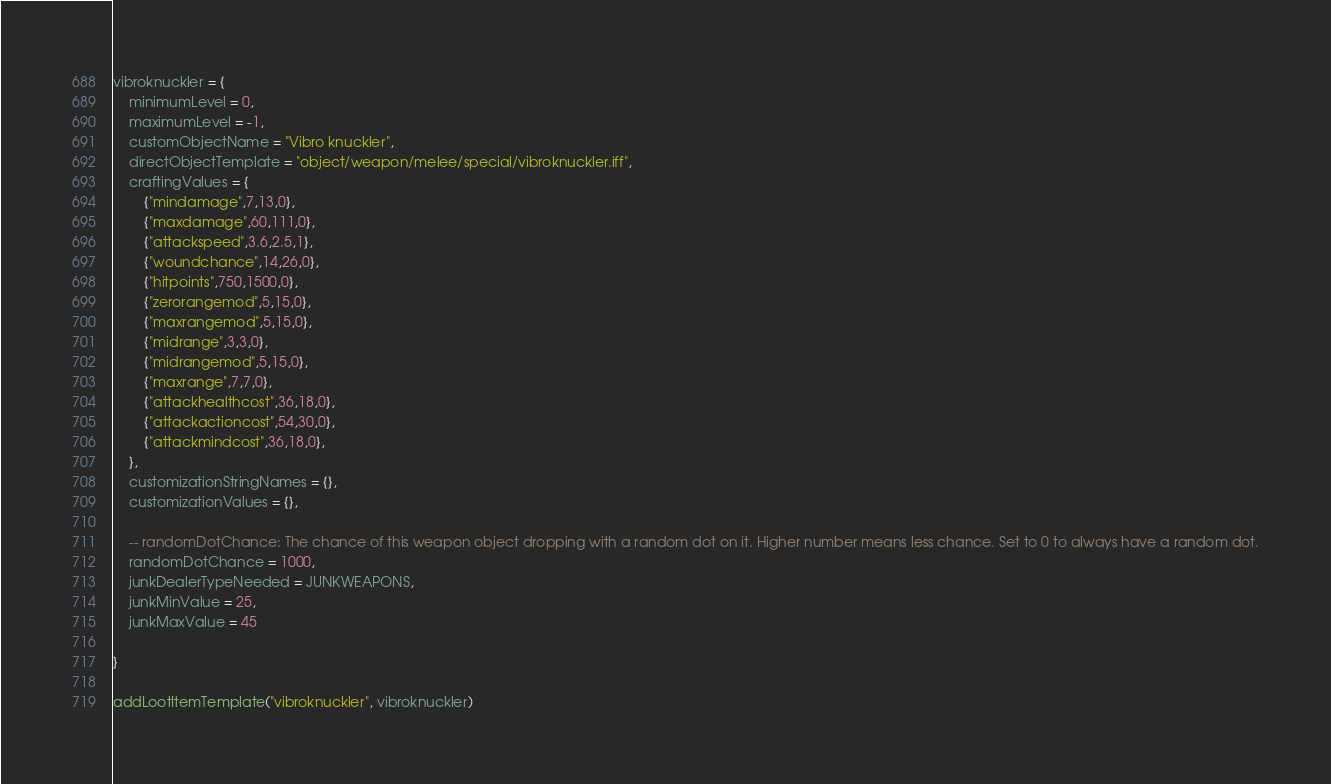<code> <loc_0><loc_0><loc_500><loc_500><_Lua_>
vibroknuckler = {
	minimumLevel = 0,
	maximumLevel = -1,
	customObjectName = "Vibro knuckler",
	directObjectTemplate = "object/weapon/melee/special/vibroknuckler.iff",
	craftingValues = {
		{"mindamage",7,13,0},
		{"maxdamage",60,111,0},
		{"attackspeed",3.6,2.5,1},
		{"woundchance",14,26,0},
		{"hitpoints",750,1500,0},
		{"zerorangemod",5,15,0},
		{"maxrangemod",5,15,0},
		{"midrange",3,3,0},
		{"midrangemod",5,15,0},
		{"maxrange",7,7,0},
		{"attackhealthcost",36,18,0},
		{"attackactioncost",54,30,0},
		{"attackmindcost",36,18,0},
	},
	customizationStringNames = {},
	customizationValues = {},

	-- randomDotChance: The chance of this weapon object dropping with a random dot on it. Higher number means less chance. Set to 0 to always have a random dot.
	randomDotChance = 1000,
	junkDealerTypeNeeded = JUNKWEAPONS,
	junkMinValue = 25,
	junkMaxValue = 45

}

addLootItemTemplate("vibroknuckler", vibroknuckler)
</code> 